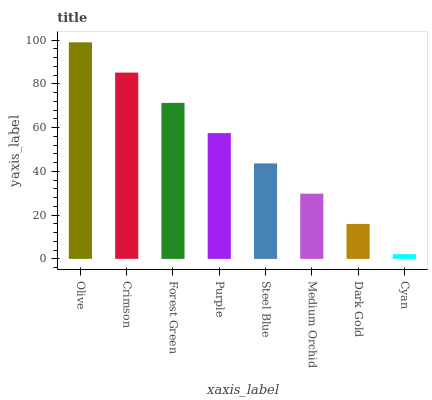Is Cyan the minimum?
Answer yes or no. Yes. Is Olive the maximum?
Answer yes or no. Yes. Is Crimson the minimum?
Answer yes or no. No. Is Crimson the maximum?
Answer yes or no. No. Is Olive greater than Crimson?
Answer yes or no. Yes. Is Crimson less than Olive?
Answer yes or no. Yes. Is Crimson greater than Olive?
Answer yes or no. No. Is Olive less than Crimson?
Answer yes or no. No. Is Purple the high median?
Answer yes or no. Yes. Is Steel Blue the low median?
Answer yes or no. Yes. Is Medium Orchid the high median?
Answer yes or no. No. Is Olive the low median?
Answer yes or no. No. 